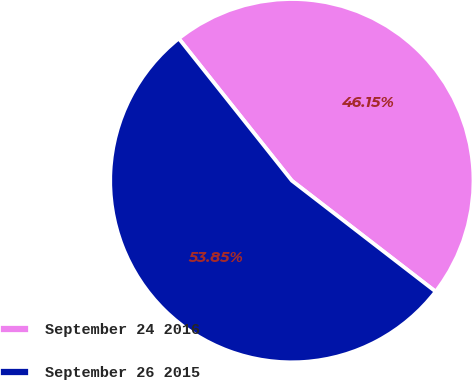<chart> <loc_0><loc_0><loc_500><loc_500><pie_chart><fcel>September 24 2016<fcel>September 26 2015<nl><fcel>46.15%<fcel>53.85%<nl></chart> 